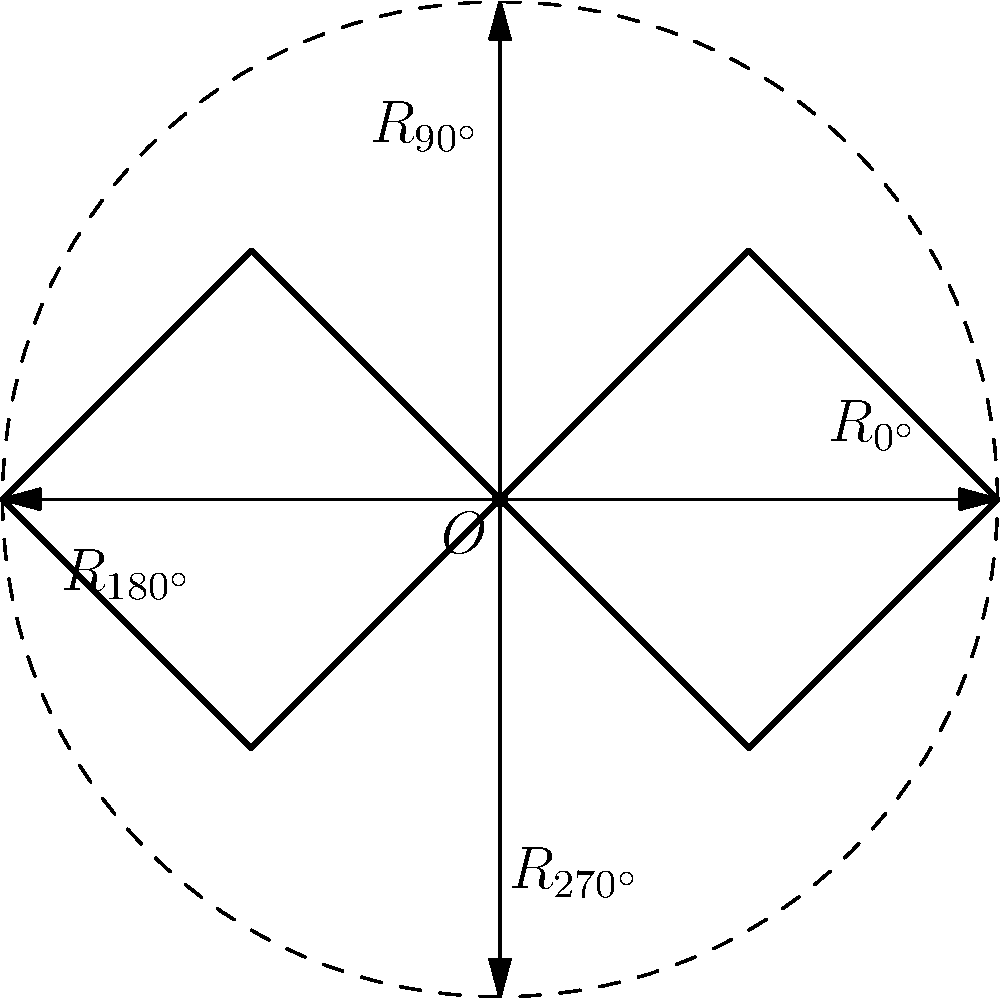Consider the double-headed eagle in the Russian coat of arms, as shown in the figure. What is the order of the rotational symmetry group of this symbol? Explain your reasoning using group theory concepts. Let's approach this step-by-step:

1) First, we need to identify the rotational symmetries of the double-headed eagle. From the diagram, we can see that the eagle remains unchanged under the following rotations about its center $O$:
   
   - $R_{0^{\circ}}$ (identity)
   - $R_{90^{\circ}}$ (90-degree rotation)
   - $R_{180^{\circ}}$ (180-degree rotation)
   - $R_{270^{\circ}}$ (270-degree rotation)

2) These rotations form a group under composition. Let's call this group $G$.

3) The elements of $G$ are $\{R_{0^{\circ}}, R_{90^{\circ}}, R_{180^{\circ}}, R_{270^{\circ}}\}$.

4) We can verify that:
   - The identity element is $R_{0^{\circ}}$
   - Each element has an inverse in the group
   - The group is closed under composition
   - The operation is associative

5) This group is isomorphic to the cyclic group $C_4$, which has order 4.

6) Therefore, the order of the rotational symmetry group of the double-headed eagle is 4.

This result aligns with the symbolism of the double-headed eagle, representing the unity and strength of Russia looking both east and west.
Answer: 4 